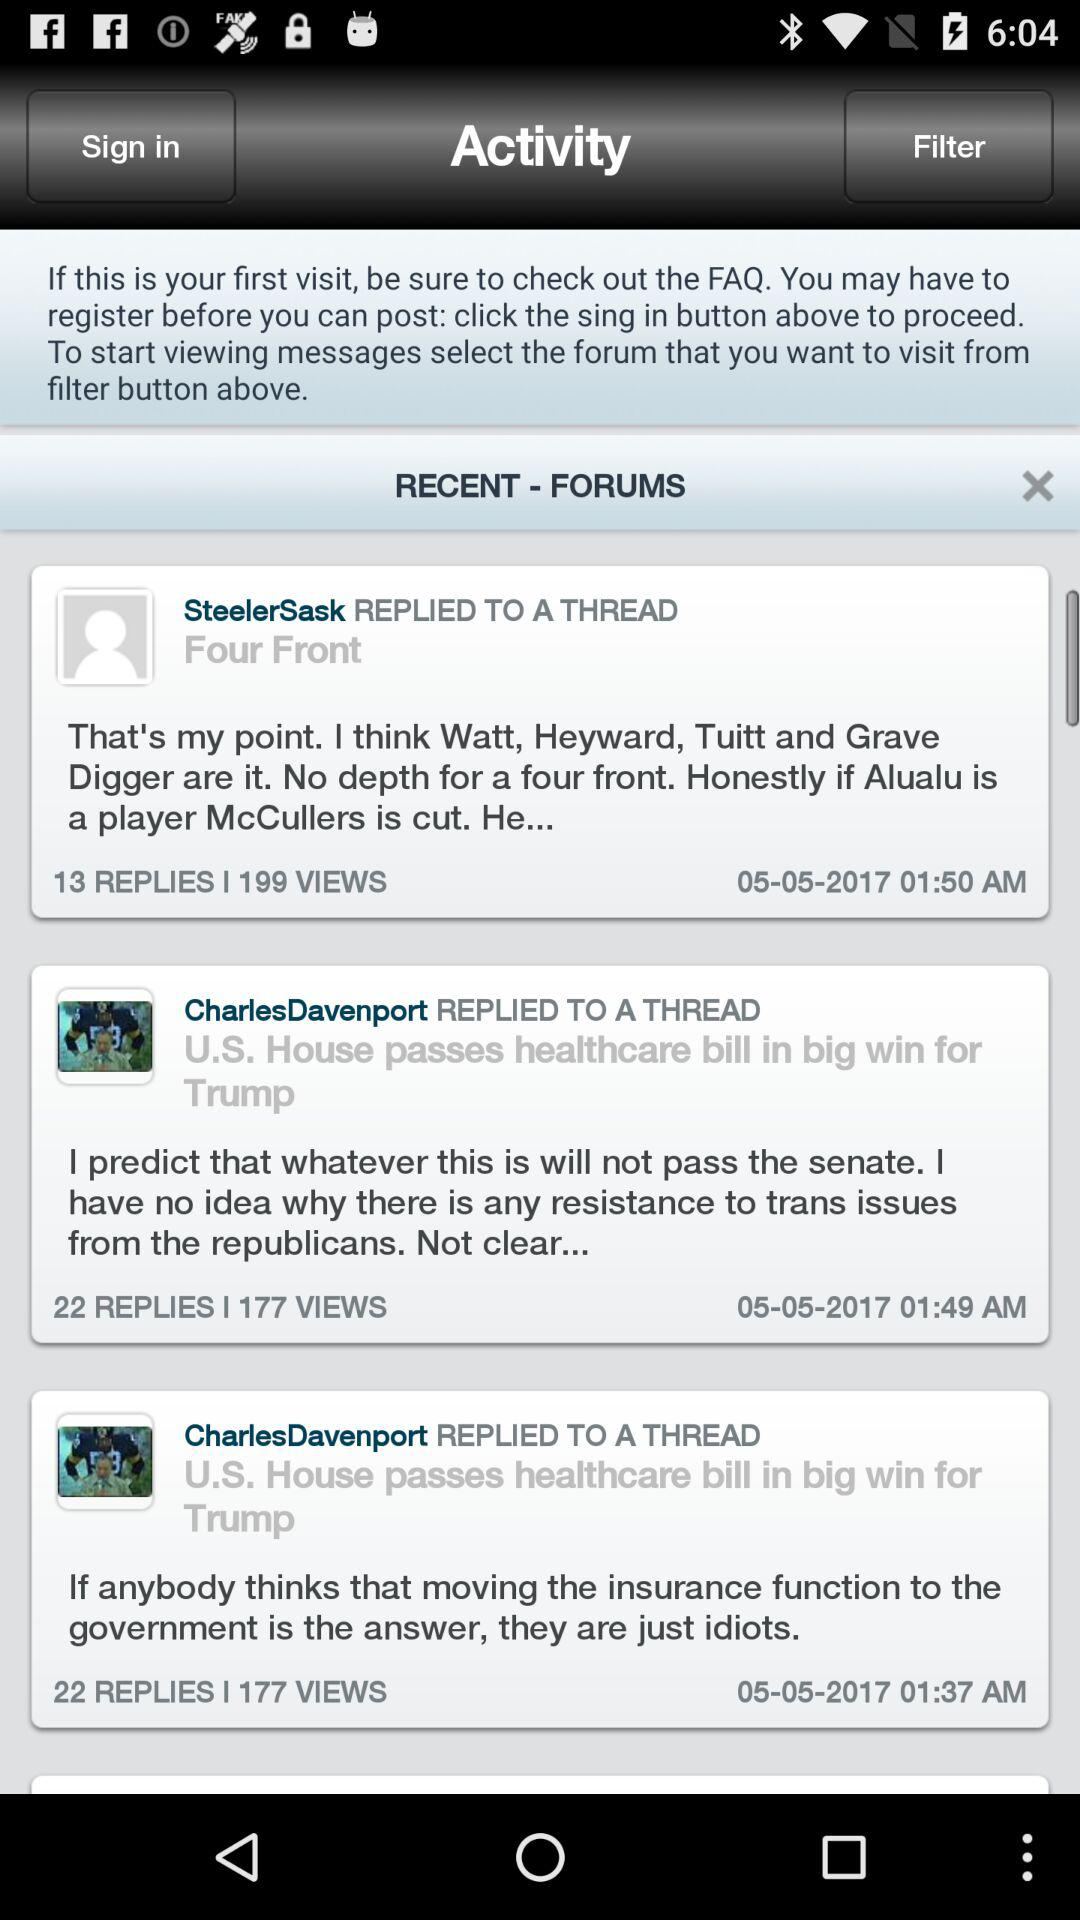On what date did "SteelerSask" reply to a thread? "SteelerSask" did reply to a thread on May 5, 2017. 